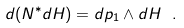<formula> <loc_0><loc_0><loc_500><loc_500>d ( N ^ { * } d H ) = d p _ { 1 } \wedge d H \ .</formula> 